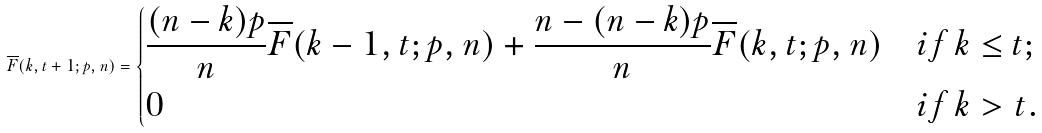Convert formula to latex. <formula><loc_0><loc_0><loc_500><loc_500>\overline { F } ( k , t + 1 ; p , n ) = \begin{dcases} \frac { ( n - k ) p } { n } \overline { F } ( k - 1 , t ; p , n ) + \frac { n - ( n - k ) p } { n } \overline { F } ( k , t ; p , n ) & i f \, k \leq t ; \\ 0 & i f \, k > t . \end{dcases}</formula> 